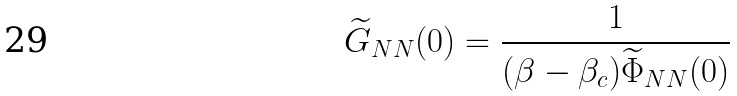Convert formula to latex. <formula><loc_0><loc_0><loc_500><loc_500>\widetilde { G } _ { N N } ( 0 ) = \frac { 1 } { ( \beta - \beta _ { c } ) \widetilde { \Phi } _ { N N } ( 0 ) }</formula> 